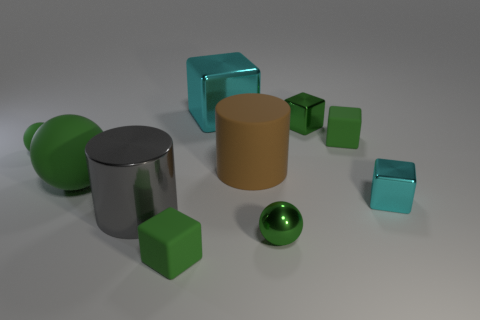There is a ball that is in front of the large cylinder that is in front of the tiny cyan object; what number of small shiny objects are behind it?
Make the answer very short. 2. How big is the rubber block that is right of the small shiny ball?
Offer a very short reply. Small. How many cyan metallic objects have the same size as the gray metallic cylinder?
Provide a succinct answer. 1. There is a green shiny ball; is it the same size as the cyan metal cube right of the big brown rubber object?
Your answer should be compact. Yes. What number of things are big green rubber things or big rubber cylinders?
Give a very brief answer. 2. How many metallic cubes are the same color as the metallic cylinder?
Keep it short and to the point. 0. There is a green thing that is the same size as the brown thing; what shape is it?
Make the answer very short. Sphere. Is there a large rubber thing that has the same shape as the big gray metal thing?
Your answer should be very brief. Yes. How many tiny red blocks have the same material as the large cyan cube?
Offer a very short reply. 0. Does the big cylinder behind the small cyan thing have the same material as the tiny cyan block?
Give a very brief answer. No. 